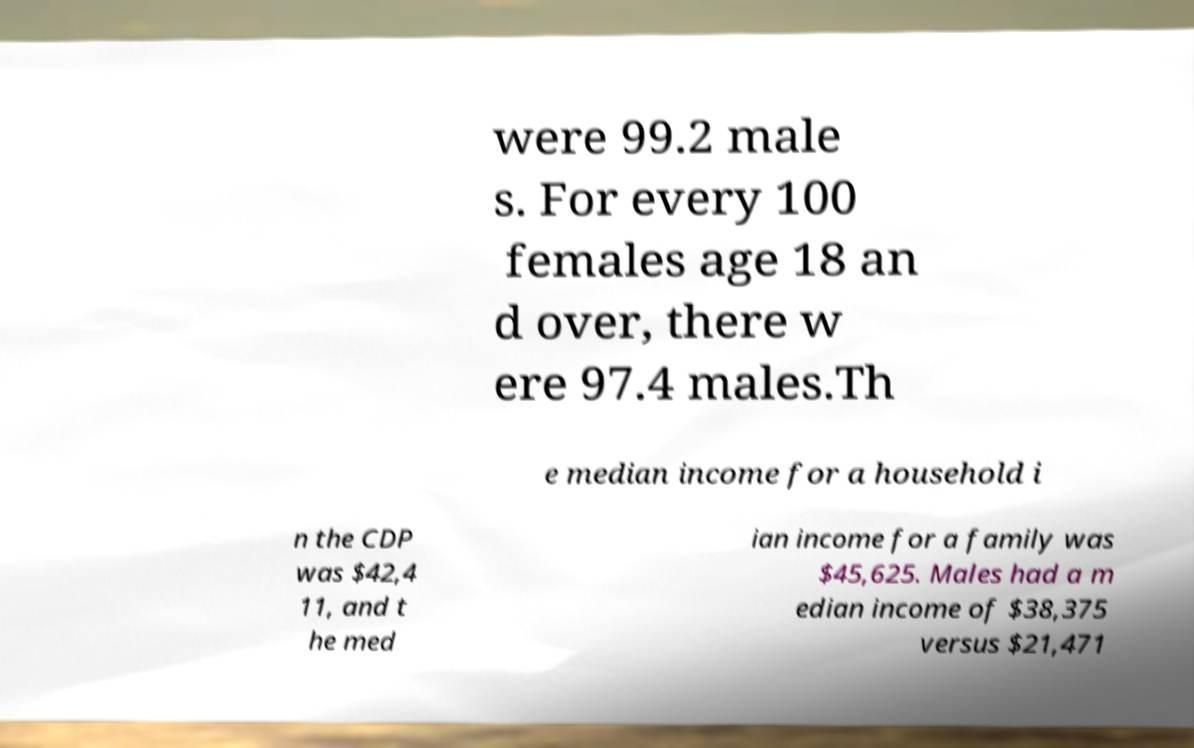I need the written content from this picture converted into text. Can you do that? were 99.2 male s. For every 100 females age 18 an d over, there w ere 97.4 males.Th e median income for a household i n the CDP was $42,4 11, and t he med ian income for a family was $45,625. Males had a m edian income of $38,375 versus $21,471 